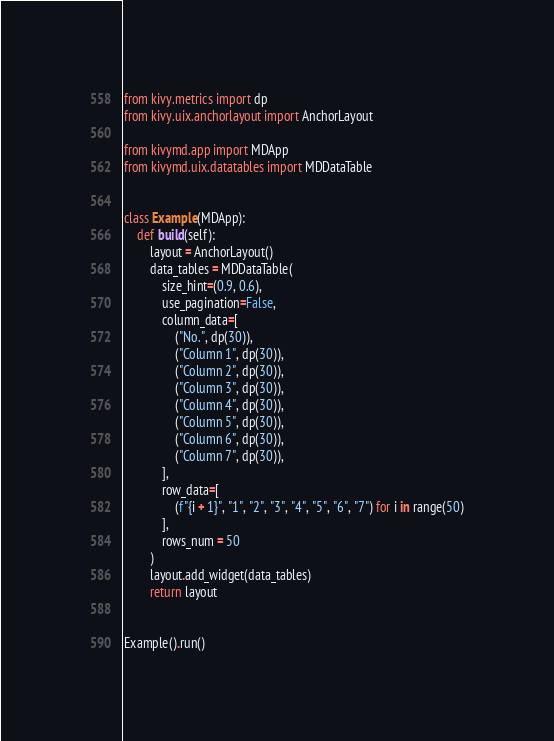Convert code to text. <code><loc_0><loc_0><loc_500><loc_500><_Python_>from kivy.metrics import dp
from kivy.uix.anchorlayout import AnchorLayout

from kivymd.app import MDApp
from kivymd.uix.datatables import MDDataTable


class Example(MDApp):
    def build(self):
        layout = AnchorLayout()
        data_tables = MDDataTable(
            size_hint=(0.9, 0.6),
            use_pagination=False,
            column_data=[
                ("No.", dp(30)),
                ("Column 1", dp(30)),
                ("Column 2", dp(30)),
                ("Column 3", dp(30)),
                ("Column 4", dp(30)),
                ("Column 5", dp(30)),
                ("Column 6", dp(30)),
                ("Column 7", dp(30)),
            ],
            row_data=[
                (f"{i + 1}", "1", "2", "3", "4", "5", "6", "7") for i in range(50)
            ],
            rows_num = 50
        )
        layout.add_widget(data_tables)
        return layout


Example().run()</code> 